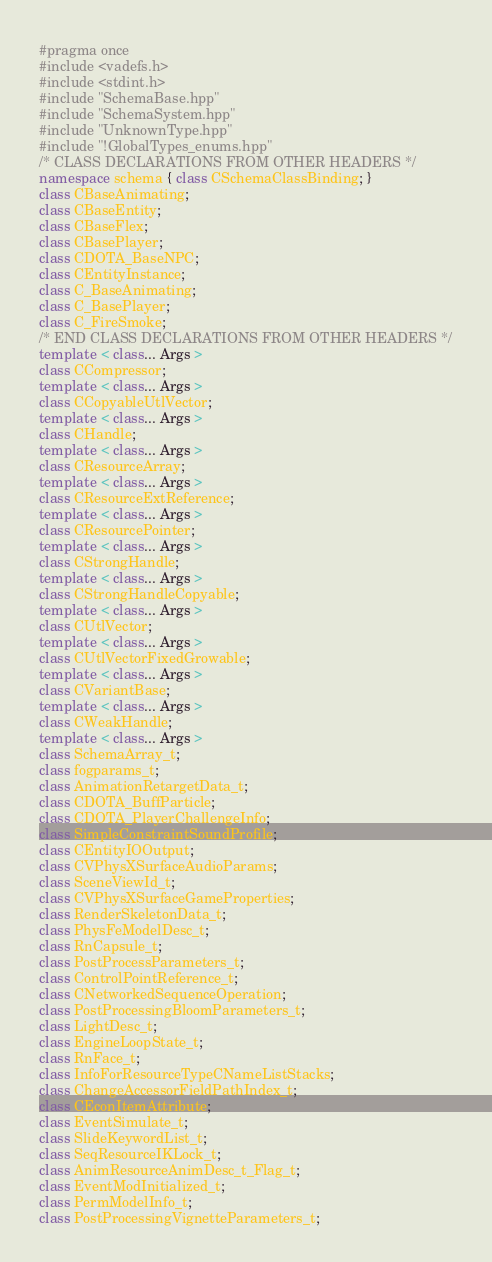Convert code to text. <code><loc_0><loc_0><loc_500><loc_500><_C++_>#pragma once
#include <vadefs.h>
#include <stdint.h>
#include "SchemaBase.hpp"
#include "SchemaSystem.hpp"
#include "UnknownType.hpp"
#include "!GlobalTypes_enums.hpp"
/* CLASS DECLARATIONS FROM OTHER HEADERS */
namespace schema { class CSchemaClassBinding; }
class CBaseAnimating;
class CBaseEntity;
class CBaseFlex;
class CBasePlayer;
class CDOTA_BaseNPC;
class CEntityInstance;
class C_BaseAnimating;
class C_BasePlayer;
class C_FireSmoke;
/* END CLASS DECLARATIONS FROM OTHER HEADERS */
template < class... Args >
class CCompressor;
template < class... Args >
class CCopyableUtlVector;
template < class... Args >
class CHandle;
template < class... Args >
class CResourceArray;
template < class... Args >
class CResourceExtReference;
template < class... Args >
class CResourcePointer;
template < class... Args >
class CStrongHandle;
template < class... Args >
class CStrongHandleCopyable;
template < class... Args >
class CUtlVector;
template < class... Args >
class CUtlVectorFixedGrowable;
template < class... Args >
class CVariantBase;
template < class... Args >
class CWeakHandle;
template < class... Args >
class SchemaArray_t;
class fogparams_t;
class AnimationRetargetData_t;
class CDOTA_BuffParticle;
class CDOTA_PlayerChallengeInfo;
class SimpleConstraintSoundProfile;
class CEntityIOOutput;
class CVPhysXSurfaceAudioParams;
class SceneViewId_t;
class CVPhysXSurfaceGameProperties;
class RenderSkeletonData_t;
class PhysFeModelDesc_t;
class RnCapsule_t;
class PostProcessParameters_t;
class ControlPointReference_t;
class CNetworkedSequenceOperation;
class PostProcessingBloomParameters_t;
class LightDesc_t;
class EngineLoopState_t;
class RnFace_t;
class InfoForResourceTypeCNameListStacks;
class ChangeAccessorFieldPathIndex_t;
class CEconItemAttribute;
class EventSimulate_t;
class SlideKeywordList_t;
class SeqResourceIKLock_t;
class AnimResourceAnimDesc_t_Flag_t;
class EventModInitialized_t;
class PermModelInfo_t;
class PostProcessingVignetteParameters_t;</code> 